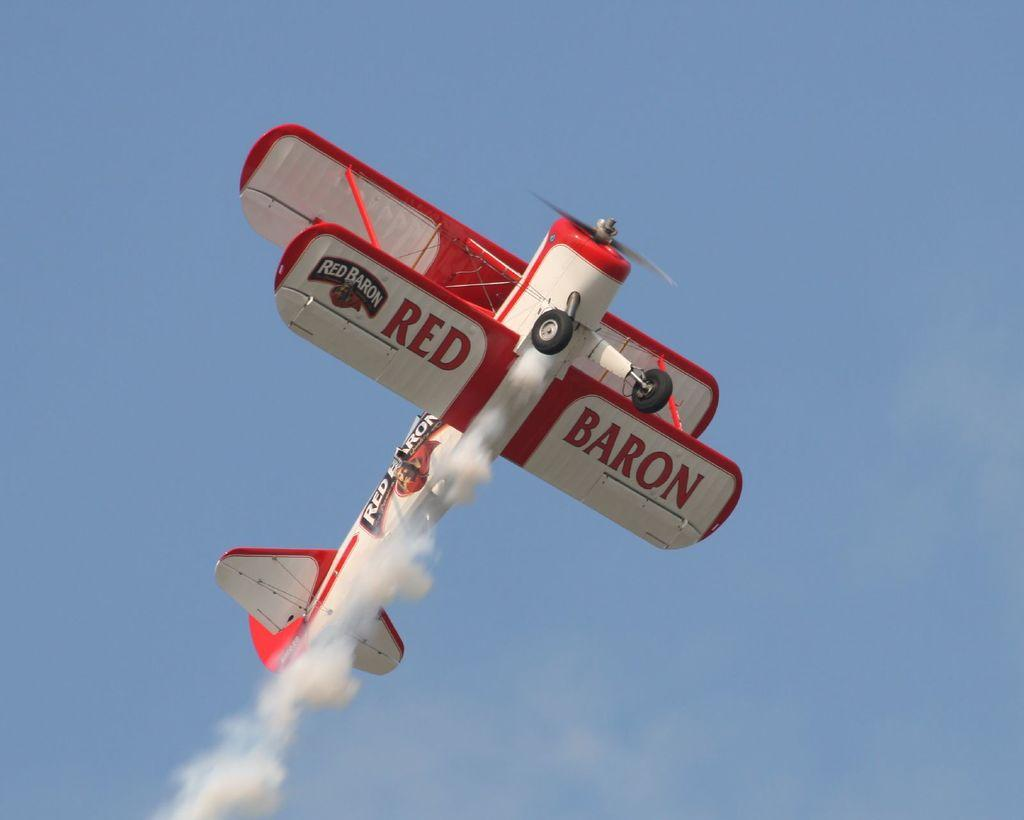What is the main subject of the image? The main subject of the image is an aircraft. What is the aircraft doing in the image? The aircraft is flying in the air. What colors can be seen on the aircraft? The aircraft is in white and red color. What else can be seen in the image besides the aircraft? There is smoke visible in the image. What is the color of the sky in the image? The sky is blue in the image. What type of lettuce is being served at the club in the image? There is no lettuce, club, or any indication of food being served in the image; it features an aircraft flying in the air. 